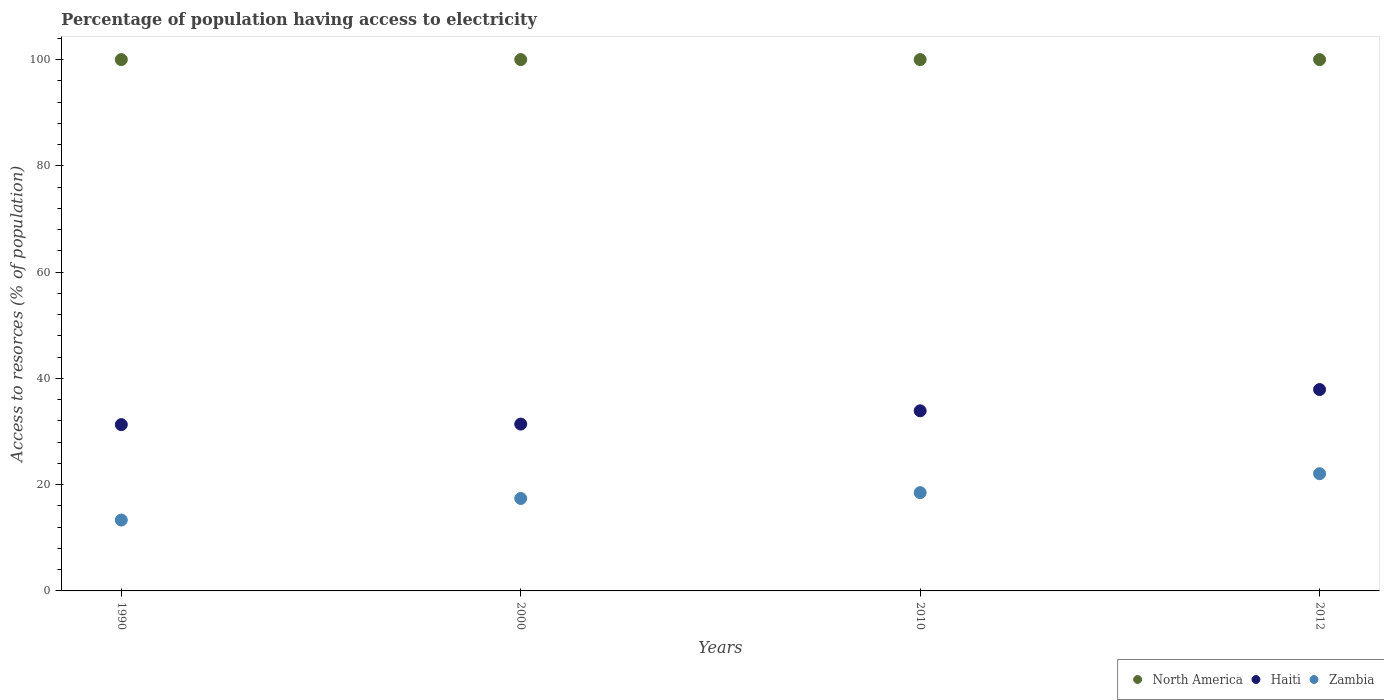What is the percentage of population having access to electricity in Haiti in 2010?
Give a very brief answer. 33.9. Across all years, what is the maximum percentage of population having access to electricity in Zambia?
Offer a terse response. 22.06. Across all years, what is the minimum percentage of population having access to electricity in North America?
Ensure brevity in your answer.  100. In which year was the percentage of population having access to electricity in Haiti maximum?
Your answer should be compact. 2012. In which year was the percentage of population having access to electricity in Zambia minimum?
Your answer should be very brief. 1990. What is the total percentage of population having access to electricity in Haiti in the graph?
Keep it short and to the point. 134.5. What is the difference between the percentage of population having access to electricity in Haiti in 1990 and that in 2012?
Your answer should be very brief. -6.6. What is the difference between the percentage of population having access to electricity in Haiti in 2000 and the percentage of population having access to electricity in Zambia in 2012?
Offer a terse response. 9.34. What is the average percentage of population having access to electricity in Haiti per year?
Provide a short and direct response. 33.62. In the year 2000, what is the difference between the percentage of population having access to electricity in Zambia and percentage of population having access to electricity in Haiti?
Your response must be concise. -14. In how many years, is the percentage of population having access to electricity in Zambia greater than 44 %?
Keep it short and to the point. 0. What is the ratio of the percentage of population having access to electricity in Haiti in 2010 to that in 2012?
Ensure brevity in your answer.  0.89. What is the difference between the highest and the second highest percentage of population having access to electricity in North America?
Make the answer very short. 0. What is the difference between the highest and the lowest percentage of population having access to electricity in Zambia?
Make the answer very short. 8.72. In how many years, is the percentage of population having access to electricity in North America greater than the average percentage of population having access to electricity in North America taken over all years?
Your answer should be very brief. 0. Is the percentage of population having access to electricity in North America strictly greater than the percentage of population having access to electricity in Haiti over the years?
Keep it short and to the point. Yes. Is the percentage of population having access to electricity in Haiti strictly less than the percentage of population having access to electricity in Zambia over the years?
Provide a short and direct response. No. How many dotlines are there?
Your answer should be very brief. 3. Are the values on the major ticks of Y-axis written in scientific E-notation?
Give a very brief answer. No. Does the graph contain any zero values?
Offer a terse response. No. Where does the legend appear in the graph?
Offer a very short reply. Bottom right. How are the legend labels stacked?
Offer a terse response. Horizontal. What is the title of the graph?
Make the answer very short. Percentage of population having access to electricity. Does "Israel" appear as one of the legend labels in the graph?
Your answer should be very brief. No. What is the label or title of the X-axis?
Ensure brevity in your answer.  Years. What is the label or title of the Y-axis?
Give a very brief answer. Access to resorces (% of population). What is the Access to resorces (% of population) of North America in 1990?
Your response must be concise. 100. What is the Access to resorces (% of population) of Haiti in 1990?
Make the answer very short. 31.3. What is the Access to resorces (% of population) in Zambia in 1990?
Keep it short and to the point. 13.34. What is the Access to resorces (% of population) of Haiti in 2000?
Your answer should be compact. 31.4. What is the Access to resorces (% of population) in Zambia in 2000?
Offer a very short reply. 17.4. What is the Access to resorces (% of population) in North America in 2010?
Make the answer very short. 100. What is the Access to resorces (% of population) in Haiti in 2010?
Give a very brief answer. 33.9. What is the Access to resorces (% of population) of Zambia in 2010?
Your answer should be compact. 18.5. What is the Access to resorces (% of population) in North America in 2012?
Provide a succinct answer. 100. What is the Access to resorces (% of population) in Haiti in 2012?
Provide a short and direct response. 37.9. What is the Access to resorces (% of population) in Zambia in 2012?
Offer a very short reply. 22.06. Across all years, what is the maximum Access to resorces (% of population) in North America?
Give a very brief answer. 100. Across all years, what is the maximum Access to resorces (% of population) in Haiti?
Ensure brevity in your answer.  37.9. Across all years, what is the maximum Access to resorces (% of population) in Zambia?
Offer a very short reply. 22.06. Across all years, what is the minimum Access to resorces (% of population) in Haiti?
Ensure brevity in your answer.  31.3. Across all years, what is the minimum Access to resorces (% of population) of Zambia?
Your answer should be compact. 13.34. What is the total Access to resorces (% of population) in Haiti in the graph?
Ensure brevity in your answer.  134.5. What is the total Access to resorces (% of population) of Zambia in the graph?
Provide a short and direct response. 71.3. What is the difference between the Access to resorces (% of population) of North America in 1990 and that in 2000?
Your answer should be compact. 0. What is the difference between the Access to resorces (% of population) of Zambia in 1990 and that in 2000?
Give a very brief answer. -4.06. What is the difference between the Access to resorces (% of population) in Haiti in 1990 and that in 2010?
Offer a terse response. -2.6. What is the difference between the Access to resorces (% of population) in Zambia in 1990 and that in 2010?
Your answer should be very brief. -5.16. What is the difference between the Access to resorces (% of population) in North America in 1990 and that in 2012?
Keep it short and to the point. 0. What is the difference between the Access to resorces (% of population) of Zambia in 1990 and that in 2012?
Your response must be concise. -8.72. What is the difference between the Access to resorces (% of population) in North America in 2000 and that in 2010?
Your answer should be compact. 0. What is the difference between the Access to resorces (% of population) in North America in 2000 and that in 2012?
Give a very brief answer. 0. What is the difference between the Access to resorces (% of population) in Zambia in 2000 and that in 2012?
Provide a succinct answer. -4.66. What is the difference between the Access to resorces (% of population) of North America in 2010 and that in 2012?
Ensure brevity in your answer.  0. What is the difference between the Access to resorces (% of population) in Zambia in 2010 and that in 2012?
Ensure brevity in your answer.  -3.56. What is the difference between the Access to resorces (% of population) of North America in 1990 and the Access to resorces (% of population) of Haiti in 2000?
Make the answer very short. 68.6. What is the difference between the Access to resorces (% of population) of North America in 1990 and the Access to resorces (% of population) of Zambia in 2000?
Your answer should be very brief. 82.6. What is the difference between the Access to resorces (% of population) of North America in 1990 and the Access to resorces (% of population) of Haiti in 2010?
Ensure brevity in your answer.  66.1. What is the difference between the Access to resorces (% of population) in North America in 1990 and the Access to resorces (% of population) in Zambia in 2010?
Your answer should be compact. 81.5. What is the difference between the Access to resorces (% of population) of Haiti in 1990 and the Access to resorces (% of population) of Zambia in 2010?
Provide a short and direct response. 12.8. What is the difference between the Access to resorces (% of population) in North America in 1990 and the Access to resorces (% of population) in Haiti in 2012?
Offer a terse response. 62.1. What is the difference between the Access to resorces (% of population) of North America in 1990 and the Access to resorces (% of population) of Zambia in 2012?
Give a very brief answer. 77.94. What is the difference between the Access to resorces (% of population) of Haiti in 1990 and the Access to resorces (% of population) of Zambia in 2012?
Your answer should be very brief. 9.24. What is the difference between the Access to resorces (% of population) of North America in 2000 and the Access to resorces (% of population) of Haiti in 2010?
Give a very brief answer. 66.1. What is the difference between the Access to resorces (% of population) of North America in 2000 and the Access to resorces (% of population) of Zambia in 2010?
Your answer should be compact. 81.5. What is the difference between the Access to resorces (% of population) in North America in 2000 and the Access to resorces (% of population) in Haiti in 2012?
Ensure brevity in your answer.  62.1. What is the difference between the Access to resorces (% of population) in North America in 2000 and the Access to resorces (% of population) in Zambia in 2012?
Provide a short and direct response. 77.94. What is the difference between the Access to resorces (% of population) in Haiti in 2000 and the Access to resorces (% of population) in Zambia in 2012?
Offer a terse response. 9.34. What is the difference between the Access to resorces (% of population) in North America in 2010 and the Access to resorces (% of population) in Haiti in 2012?
Your response must be concise. 62.1. What is the difference between the Access to resorces (% of population) in North America in 2010 and the Access to resorces (% of population) in Zambia in 2012?
Give a very brief answer. 77.94. What is the difference between the Access to resorces (% of population) in Haiti in 2010 and the Access to resorces (% of population) in Zambia in 2012?
Give a very brief answer. 11.84. What is the average Access to resorces (% of population) in Haiti per year?
Your answer should be very brief. 33.62. What is the average Access to resorces (% of population) in Zambia per year?
Make the answer very short. 17.83. In the year 1990, what is the difference between the Access to resorces (% of population) of North America and Access to resorces (% of population) of Haiti?
Provide a succinct answer. 68.7. In the year 1990, what is the difference between the Access to resorces (% of population) of North America and Access to resorces (% of population) of Zambia?
Provide a short and direct response. 86.66. In the year 1990, what is the difference between the Access to resorces (% of population) in Haiti and Access to resorces (% of population) in Zambia?
Provide a succinct answer. 17.96. In the year 2000, what is the difference between the Access to resorces (% of population) of North America and Access to resorces (% of population) of Haiti?
Your answer should be very brief. 68.6. In the year 2000, what is the difference between the Access to resorces (% of population) in North America and Access to resorces (% of population) in Zambia?
Provide a succinct answer. 82.6. In the year 2010, what is the difference between the Access to resorces (% of population) of North America and Access to resorces (% of population) of Haiti?
Give a very brief answer. 66.1. In the year 2010, what is the difference between the Access to resorces (% of population) of North America and Access to resorces (% of population) of Zambia?
Your answer should be very brief. 81.5. In the year 2012, what is the difference between the Access to resorces (% of population) in North America and Access to resorces (% of population) in Haiti?
Your response must be concise. 62.1. In the year 2012, what is the difference between the Access to resorces (% of population) in North America and Access to resorces (% of population) in Zambia?
Give a very brief answer. 77.94. In the year 2012, what is the difference between the Access to resorces (% of population) of Haiti and Access to resorces (% of population) of Zambia?
Make the answer very short. 15.84. What is the ratio of the Access to resorces (% of population) of Zambia in 1990 to that in 2000?
Offer a very short reply. 0.77. What is the ratio of the Access to resorces (% of population) of Haiti in 1990 to that in 2010?
Your answer should be very brief. 0.92. What is the ratio of the Access to resorces (% of population) of Zambia in 1990 to that in 2010?
Your answer should be very brief. 0.72. What is the ratio of the Access to resorces (% of population) in Haiti in 1990 to that in 2012?
Make the answer very short. 0.83. What is the ratio of the Access to resorces (% of population) of Zambia in 1990 to that in 2012?
Give a very brief answer. 0.6. What is the ratio of the Access to resorces (% of population) in Haiti in 2000 to that in 2010?
Provide a short and direct response. 0.93. What is the ratio of the Access to resorces (% of population) of Zambia in 2000 to that in 2010?
Make the answer very short. 0.94. What is the ratio of the Access to resorces (% of population) of North America in 2000 to that in 2012?
Your answer should be very brief. 1. What is the ratio of the Access to resorces (% of population) in Haiti in 2000 to that in 2012?
Provide a succinct answer. 0.83. What is the ratio of the Access to resorces (% of population) of Zambia in 2000 to that in 2012?
Provide a succinct answer. 0.79. What is the ratio of the Access to resorces (% of population) in Haiti in 2010 to that in 2012?
Keep it short and to the point. 0.89. What is the ratio of the Access to resorces (% of population) of Zambia in 2010 to that in 2012?
Offer a terse response. 0.84. What is the difference between the highest and the second highest Access to resorces (% of population) in North America?
Provide a succinct answer. 0. What is the difference between the highest and the second highest Access to resorces (% of population) in Zambia?
Keep it short and to the point. 3.56. What is the difference between the highest and the lowest Access to resorces (% of population) in North America?
Your answer should be compact. 0. What is the difference between the highest and the lowest Access to resorces (% of population) of Haiti?
Your answer should be compact. 6.6. What is the difference between the highest and the lowest Access to resorces (% of population) of Zambia?
Offer a very short reply. 8.72. 